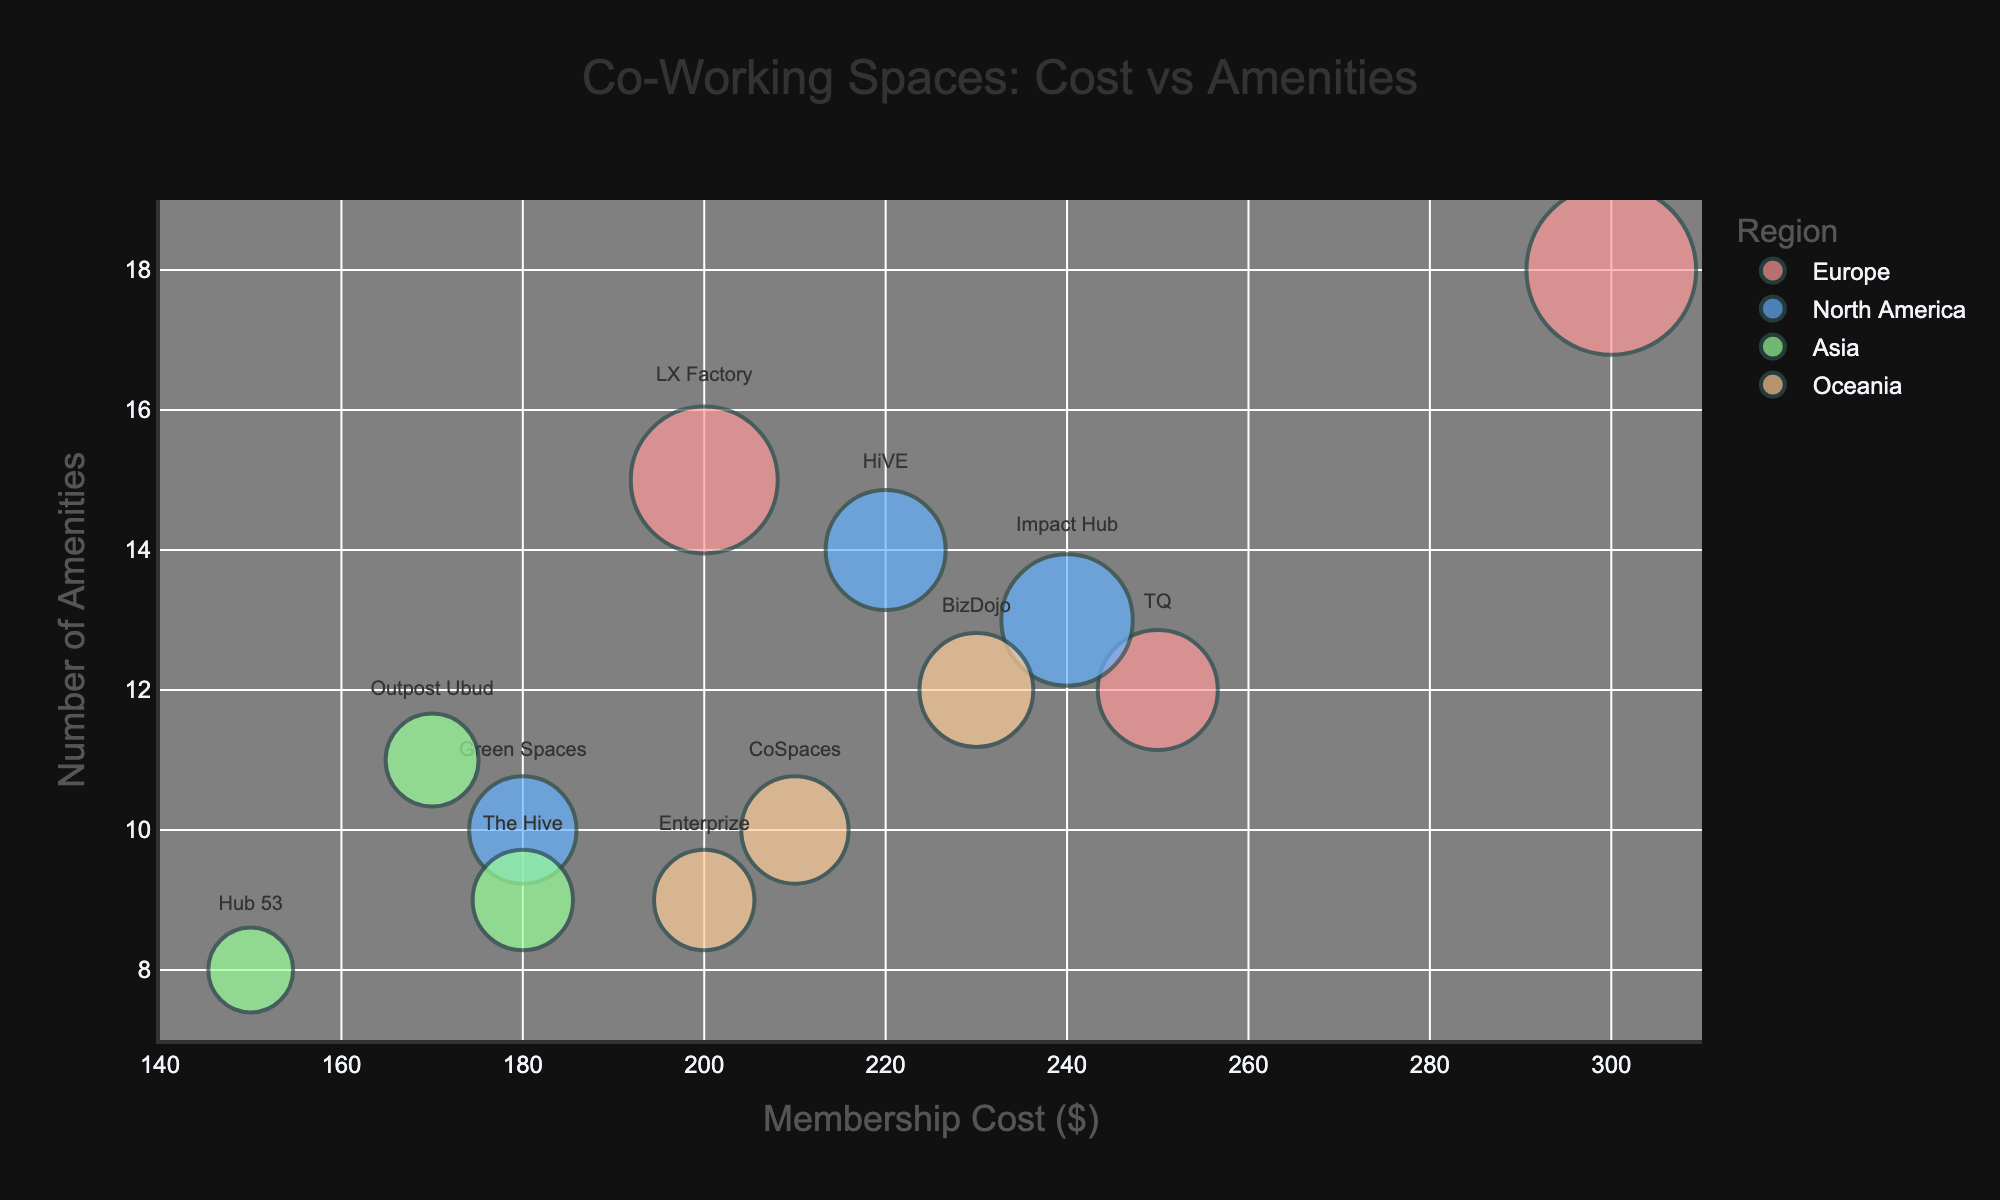What's the title of the figure? The title is usually displayed prominently near the top of the figure. It gives a clear summary of what the figure represents. In this case, the title is visible as 'Co-Working Spaces: Cost vs Amenities'.
Answer: Co-Working Spaces: Cost vs Amenities What's the color code used to represent Europe in the chart? We can identify regions by their colors in the legend. In this figure, Europe is represented using the color that matches Lisbon, Amsterdam, and Berlin. The legend shows that Europe uses a specific shade of red.
Answer: Red Which city has the highest membership cost? To find the city with the highest membership cost, look for the bubble positioned at the far right of the x-axis. The city associated with this bubble, according to the hover labels or text, is Berlin.
Answer: Berlin How many amenities does the co-working space in Gold Coast offer? Identify the bubble representing Gold Coast by its text label or hover information. The y-axis value of this bubble will provide the number of amenities. The chart shows 10 amenities for Gold Coast.
Answer: 10 Which region has the co-working space with the maximum number of seats? To find this, look for the largest bubble in the chart, as bubble size represents the number of seats. The largest bubble belongs to Berlin, located in Europe.
Answer: Europe Compare the membership cost between LX Factory in Lisbon and BizDojo in Wellington. Which one is higher? LX Factory in Lisbon and BizDojo in Wellington are identified by their text labels or hover information. The x-axis values indicate their membership costs, showing Lisbon has $200, while Wellington has $230. Wellington's cost is higher.
Answer: Wellington What region is represented by light blue in the chart? By referring to the chart's legend, we match the light blue color to the corresponding region. Light blue is used for North America.
Answer: North America If you prefer quieter, less populous places with a moderate number of amenities, what could be a good option? Look for regions with smaller and fewer crowded bubbles outside major cities. Fewer amenities can be represented by bubbles towards the lower part of the y-axis. Tasmania with Enterprize has a moderate membership cost of $200 and offers 9 amenities.
Answer: Tasmania What's the average membership cost for co-working spaces in Asia? To calculate this, sum the membership costs for all cities in Asia and divide by the number of cities. The cities and costs in Asia are Chiang Mai ($150), Bali ($170), and Ho Chi Minh City ($180). The total is $500, and there are 3 cities. The average is 500/3 ≈ $167.
Answer: $167 Which city in Europe provides the most amenities, and how many? Look at the y-axis values for each city in Europe. Mindspace in Berlin appears to offer the most with 18 amenities.
Answer: Berlin, 18 